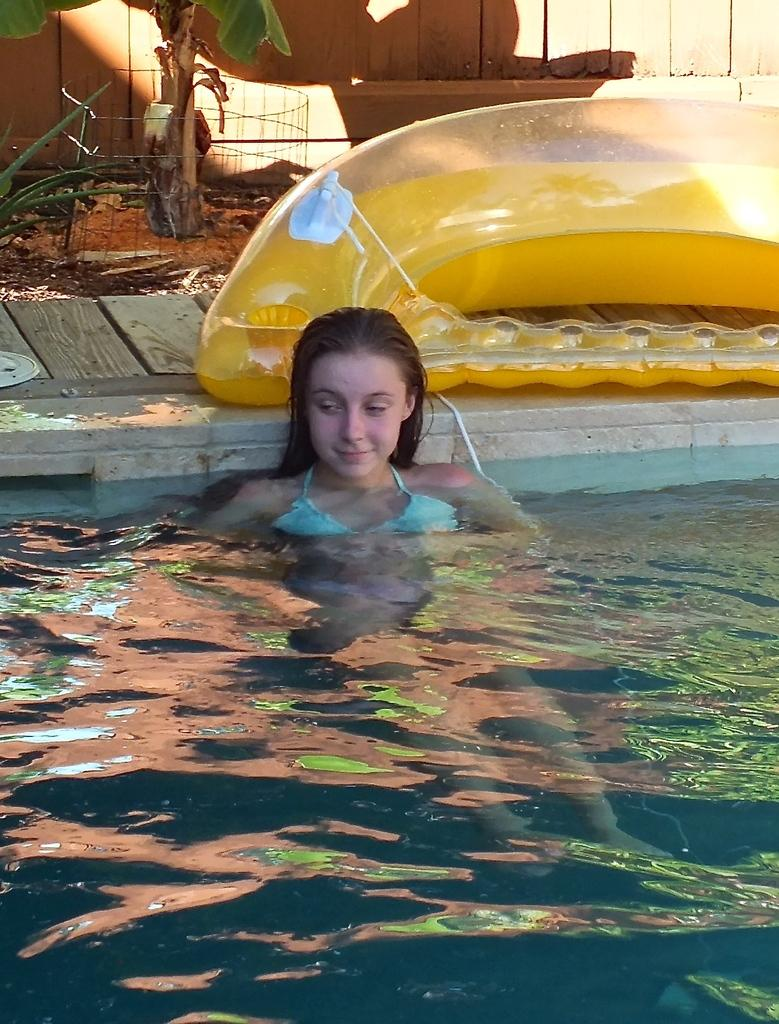What is the woman doing in the image? The woman is in the water. What can be seen on a platform in the image? There is an object on a platform. What type of barrier is present in the image? There is a fence in the image. What type of plant is on the ground in the image? There is a plant on the ground. What material is used to construct the fence in the image? The fence in the image is made of wood. What type of sheet is being used to cover the plant in the image? There is no sheet present in the image; it is a plant on the ground. What belief system is being practiced by the woman in the image? There is no indication of any belief system being practiced in the image; it is a woman in the water. 